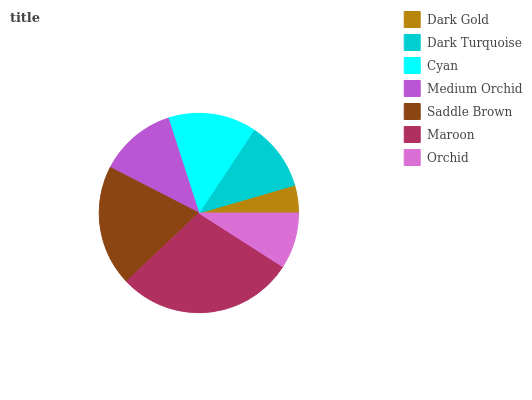Is Dark Gold the minimum?
Answer yes or no. Yes. Is Maroon the maximum?
Answer yes or no. Yes. Is Dark Turquoise the minimum?
Answer yes or no. No. Is Dark Turquoise the maximum?
Answer yes or no. No. Is Dark Turquoise greater than Dark Gold?
Answer yes or no. Yes. Is Dark Gold less than Dark Turquoise?
Answer yes or no. Yes. Is Dark Gold greater than Dark Turquoise?
Answer yes or no. No. Is Dark Turquoise less than Dark Gold?
Answer yes or no. No. Is Medium Orchid the high median?
Answer yes or no. Yes. Is Medium Orchid the low median?
Answer yes or no. Yes. Is Cyan the high median?
Answer yes or no. No. Is Orchid the low median?
Answer yes or no. No. 